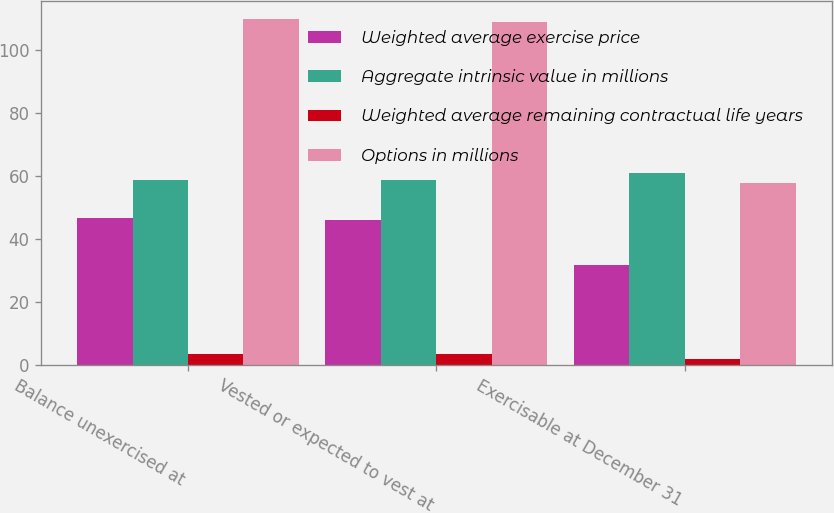Convert chart to OTSL. <chart><loc_0><loc_0><loc_500><loc_500><stacked_bar_chart><ecel><fcel>Balance unexercised at<fcel>Vested or expected to vest at<fcel>Exercisable at December 31<nl><fcel>Weighted average exercise price<fcel>46.8<fcel>46<fcel>31.7<nl><fcel>Aggregate intrinsic value in millions<fcel>58.66<fcel>58.71<fcel>61.05<nl><fcel>Weighted average remaining contractual life years<fcel>3.6<fcel>3.5<fcel>2.1<nl><fcel>Options in millions<fcel>110<fcel>109<fcel>58<nl></chart> 